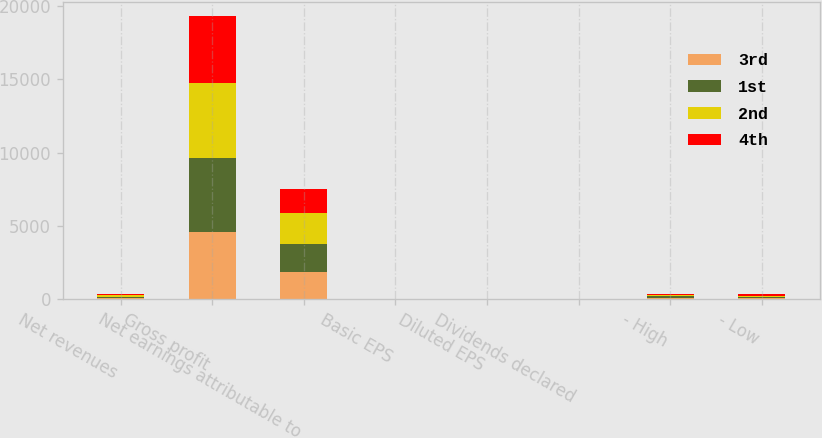Convert chart. <chart><loc_0><loc_0><loc_500><loc_500><stacked_bar_chart><ecel><fcel>Net revenues<fcel>Gross profit<fcel>Net earnings attributable to<fcel>Basic EPS<fcel>Diluted EPS<fcel>Dividends declared<fcel>- High<fcel>- Low<nl><fcel>3rd<fcel>81.175<fcel>4543<fcel>1875<fcel>1.18<fcel>1.18<fcel>0.94<fcel>87.2<fcel>75.28<nl><fcel>1st<fcel>81.175<fcel>5101<fcel>1851<fcel>1.17<fcel>1.17<fcel>0.94<fcel>91.63<fcel>81.7<nl><fcel>2nd<fcel>81.175<fcel>5122<fcel>2155<fcel>1.38<fcel>1.38<fcel>1<fcel>86.85<fcel>81.19<nl><fcel>4th<fcel>81.175<fcel>4565<fcel>1612<fcel>1.03<fcel>1.03<fcel>1<fcel>90.25<fcel>81.16<nl></chart> 